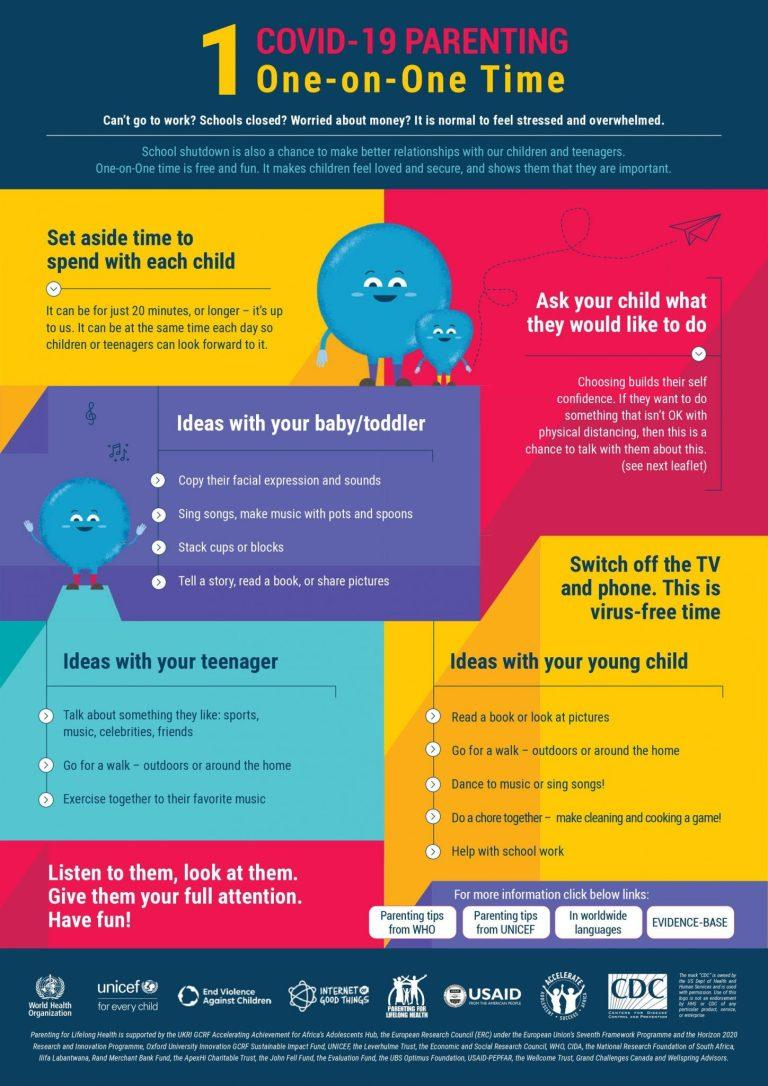Highlight a few significant elements in this photo. The third idea under the category of "ideas with your baby toddler" is stacking cups or blocks. At different stages of childhood, children generally enjoy going for walks. Specifically, young children and teenagers tend to enjoy walking as a recreational activity. Three ideas for spending time with teenagers are mentioned. It is declared that three stages of childhood are mentioned. UNICEF and WHO are the two organizations that provide parenting tips. 